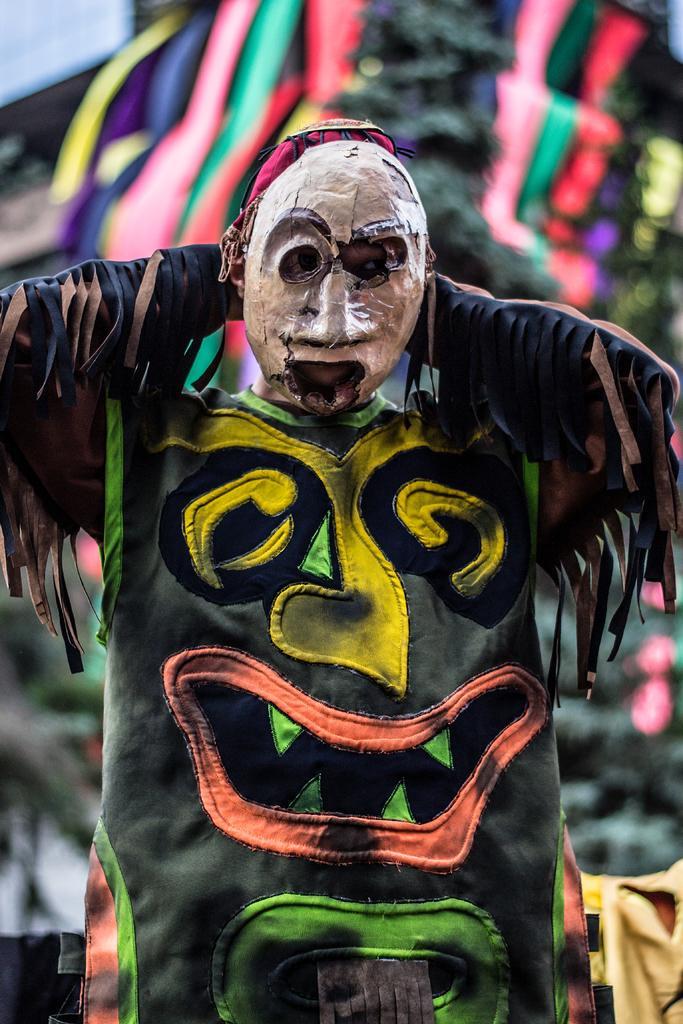Can you describe this image briefly? In this image there is a man he is wearing costumes, in the background there are cloths. 